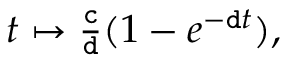Convert formula to latex. <formula><loc_0><loc_0><loc_500><loc_500>\begin{array} { r } { t \mapsto \frac { c } { d } ( 1 - e ^ { - d t } ) , } \end{array}</formula> 